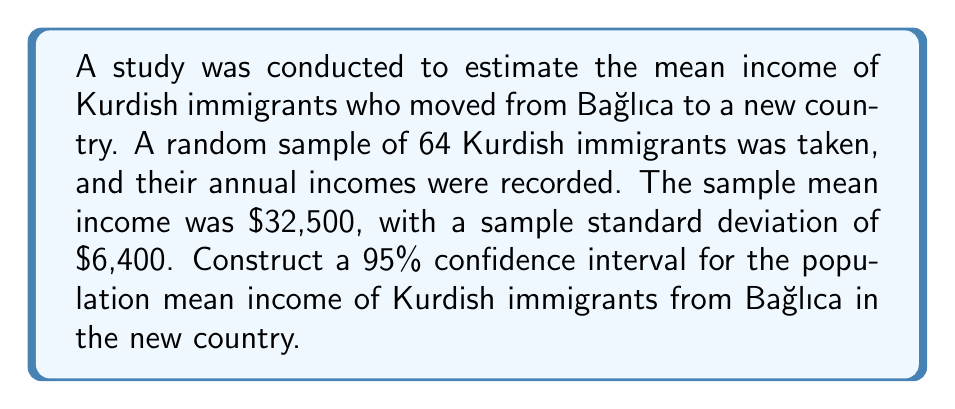Can you answer this question? To construct a confidence interval for the population mean, we'll use the formula:

$$ \text{CI} = \bar{x} \pm t_{\alpha/2} \cdot \frac{s}{\sqrt{n}} $$

Where:
$\bar{x}$ = sample mean
$t_{\alpha/2}$ = t-value for 95% confidence level with (n-1) degrees of freedom
s = sample standard deviation
n = sample size

Step 1: Identify the given information
$\bar{x} = 32,500$
$s = 6,400$
$n = 64$
Confidence level = 95%

Step 2: Find the t-value
With 95% confidence and 63 degrees of freedom (n-1 = 64-1 = 63), the t-value is approximately 1.998 (from t-distribution table).

Step 3: Calculate the margin of error
$$ \text{Margin of Error} = t_{\alpha/2} \cdot \frac{s}{\sqrt{n}} = 1.998 \cdot \frac{6,400}{\sqrt{64}} = 1,598 $$

Step 4: Calculate the confidence interval
Lower bound: $32,500 - 1,598 = 30,902$
Upper bound: $32,500 + 1,598 = 34,098$

Therefore, the 95% confidence interval for the population mean income is ($30,902, $34,098).
Answer: ($30,902, $34,098) 